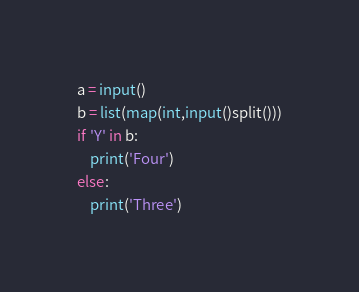Convert code to text. <code><loc_0><loc_0><loc_500><loc_500><_Python_>a = input()
b = list(map(int,input()split()))
if 'Y' in b:
    print('Four')
else:
    print('Three')</code> 